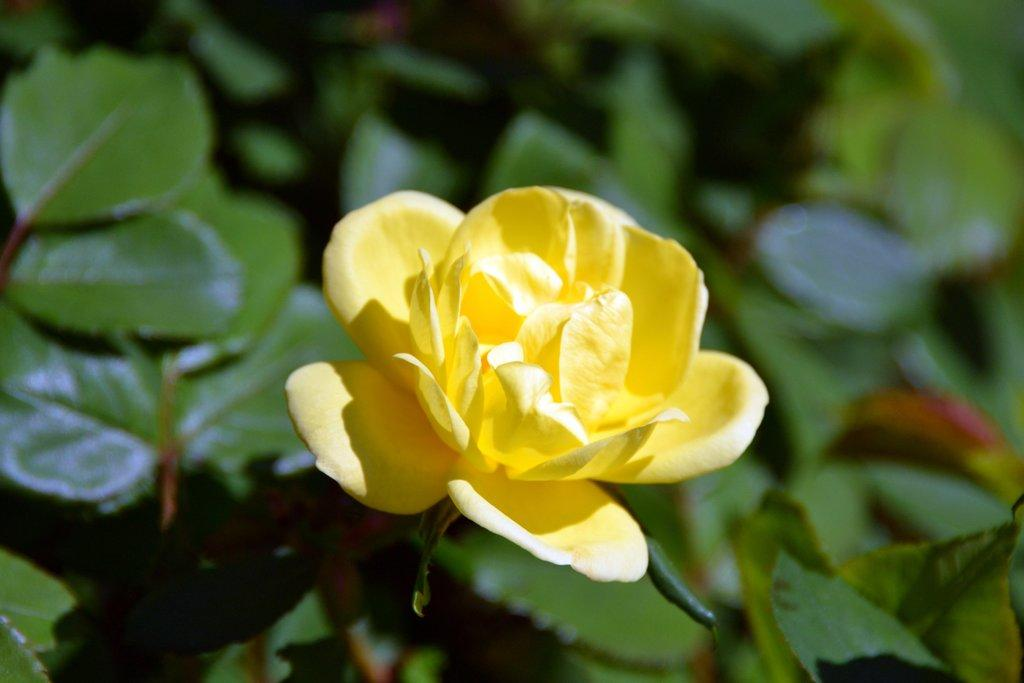What is the main subject of the image? There is a flower in the image. What can be seen in the background of the image? There are leaves visible in the background of the image. What type of oatmeal is being served in the image? There is no oatmeal present in the image; it features a flower and leaves. How does the flower help with a sore throat in the image? The image does not depict any connection between the flower and a sore throat, as it only shows a flower and leaves. 